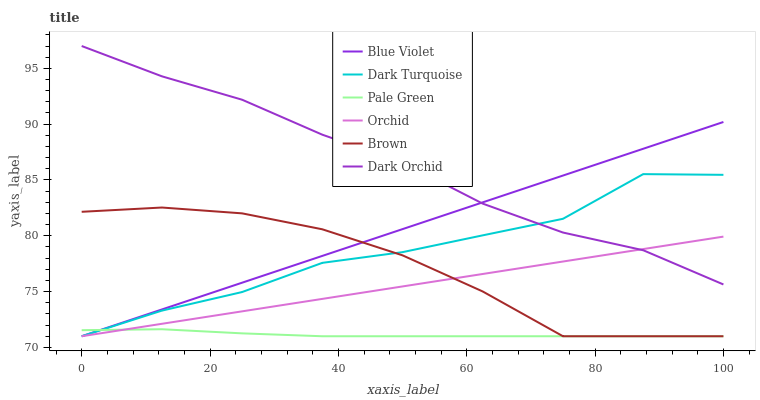Does Pale Green have the minimum area under the curve?
Answer yes or no. Yes. Does Dark Orchid have the maximum area under the curve?
Answer yes or no. Yes. Does Dark Turquoise have the minimum area under the curve?
Answer yes or no. No. Does Dark Turquoise have the maximum area under the curve?
Answer yes or no. No. Is Orchid the smoothest?
Answer yes or no. Yes. Is Dark Turquoise the roughest?
Answer yes or no. Yes. Is Dark Orchid the smoothest?
Answer yes or no. No. Is Dark Orchid the roughest?
Answer yes or no. No. Does Brown have the lowest value?
Answer yes or no. Yes. Does Dark Orchid have the lowest value?
Answer yes or no. No. Does Dark Orchid have the highest value?
Answer yes or no. Yes. Does Dark Turquoise have the highest value?
Answer yes or no. No. Is Brown less than Dark Orchid?
Answer yes or no. Yes. Is Dark Orchid greater than Pale Green?
Answer yes or no. Yes. Does Orchid intersect Dark Turquoise?
Answer yes or no. Yes. Is Orchid less than Dark Turquoise?
Answer yes or no. No. Is Orchid greater than Dark Turquoise?
Answer yes or no. No. Does Brown intersect Dark Orchid?
Answer yes or no. No. 